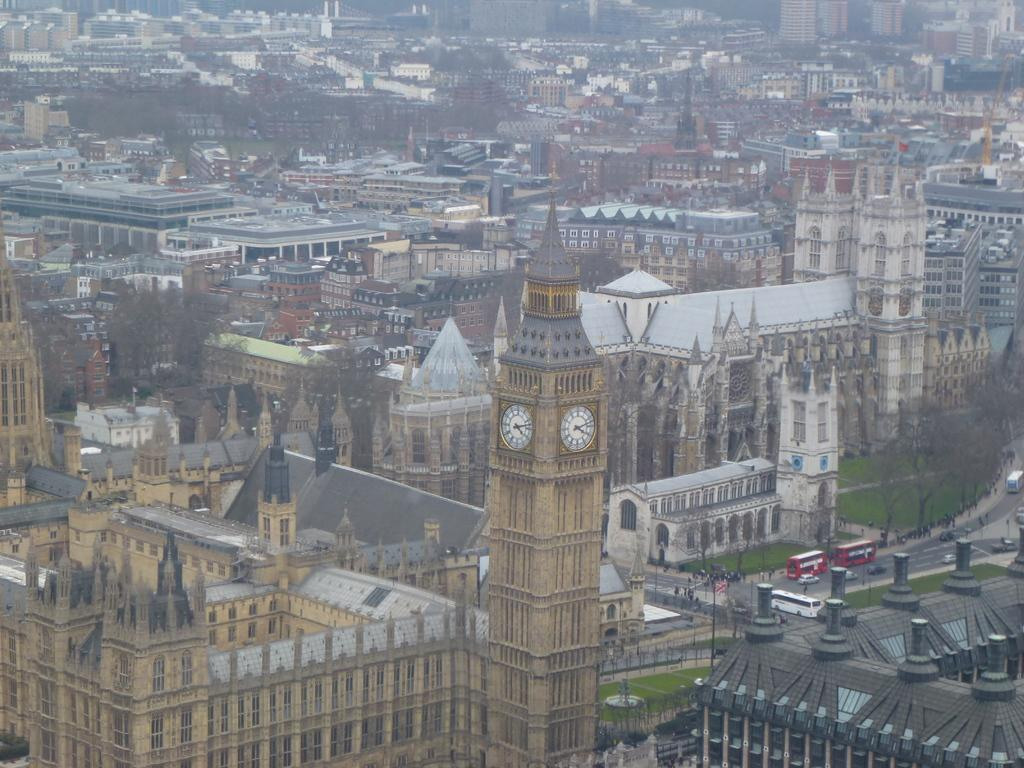What type of structures can be seen in the image? There are buildings in the image. What natural elements are present in the image? There are trees and grass in the image. What type of transportation is visible on the road in the image? There are vehicles on the road in the image. How many stars can be seen in the image? There are no stars visible in the image; it features buildings, trees, grass, and vehicles on the road. What type of flight is taking place in the image? There is no flight present in the image; it only shows buildings, trees, grass, and vehicles on the road. 